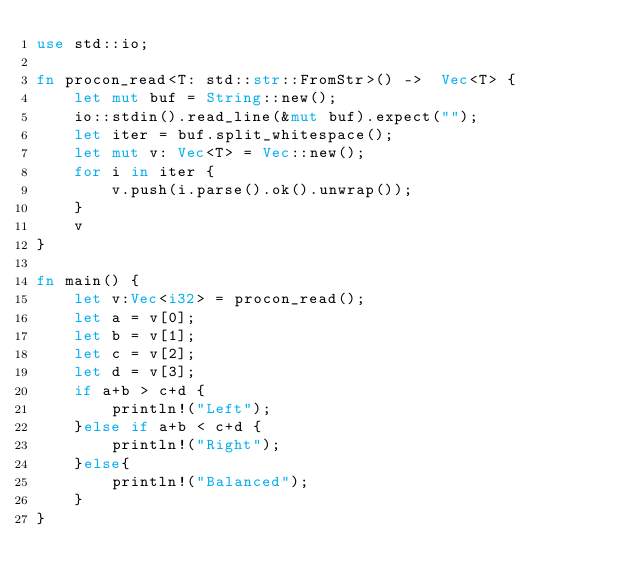<code> <loc_0><loc_0><loc_500><loc_500><_Rust_>use std::io;

fn procon_read<T: std::str::FromStr>() ->  Vec<T> {
	let mut buf = String::new();
	io::stdin().read_line(&mut buf).expect("");
	let iter = buf.split_whitespace();
	let mut v: Vec<T> = Vec::new();
	for i in iter {
		v.push(i.parse().ok().unwrap());
	}
	v
}

fn main() {
	let v:Vec<i32> = procon_read();
	let a = v[0];
	let b = v[1];
	let c = v[2];
	let d = v[3];
	if a+b > c+d {
		println!("Left");
	}else if a+b < c+d {
		println!("Right");
	}else{
		println!("Balanced");
	}
}</code> 